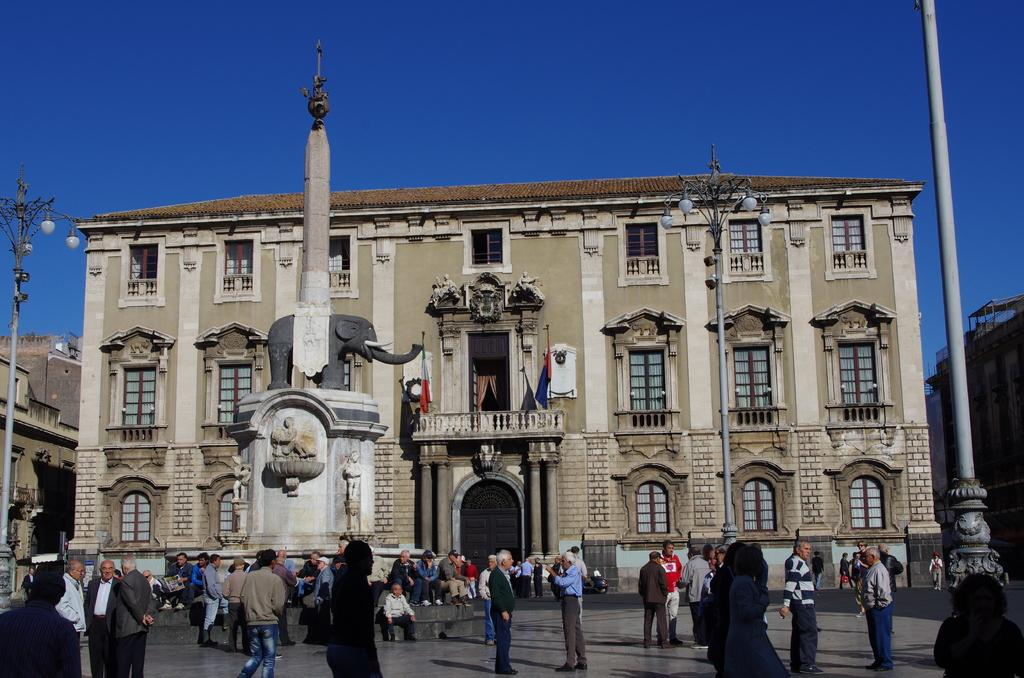Who or what can be seen at the bottom side of the image? There are people at the bottom side of the image. What can be seen in the distance behind the people? There are buildings, poles, flags, and a sculpture in the background. What is visible in the sky in the image? The sky is visible in the background of the image. What type of meat can be seen cooking on the grill in the image? There is no grill or meat present in the image. What color is the flame coming from the grill in the image? There is no grill or flame present in the image. 